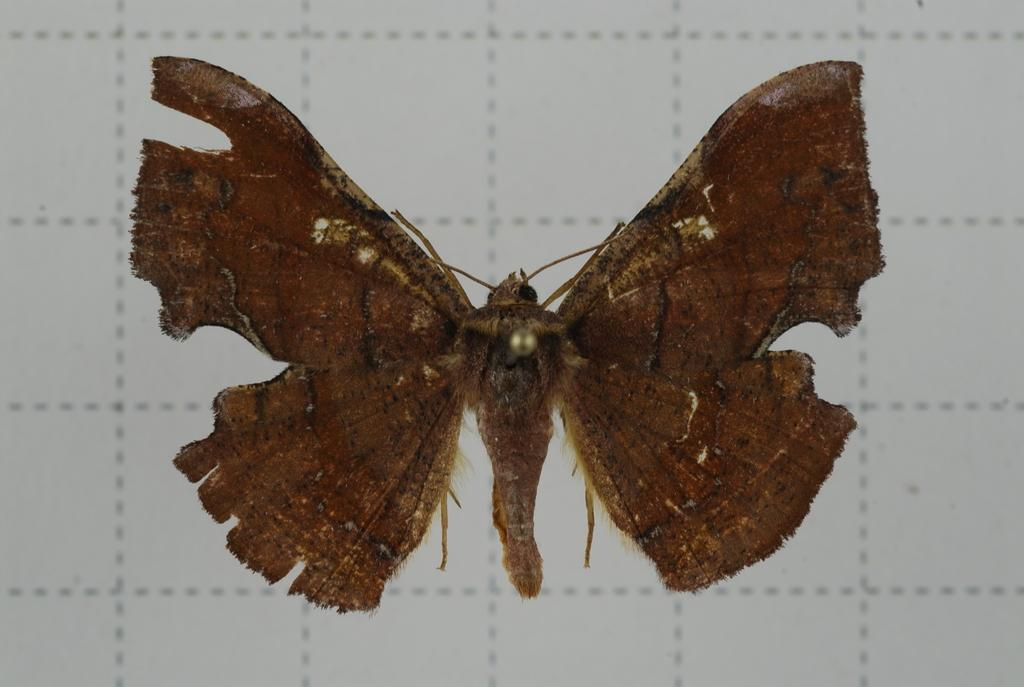What type of animal can be seen in the image? There is a butterfly in the image. What is the background of the image? There is a white wall with checks in the background of the image. What flavor of mark can be seen on the manager's shirt in the image? There is no manager or mark present in the image; it only features a butterfly and a white wall with checks. 